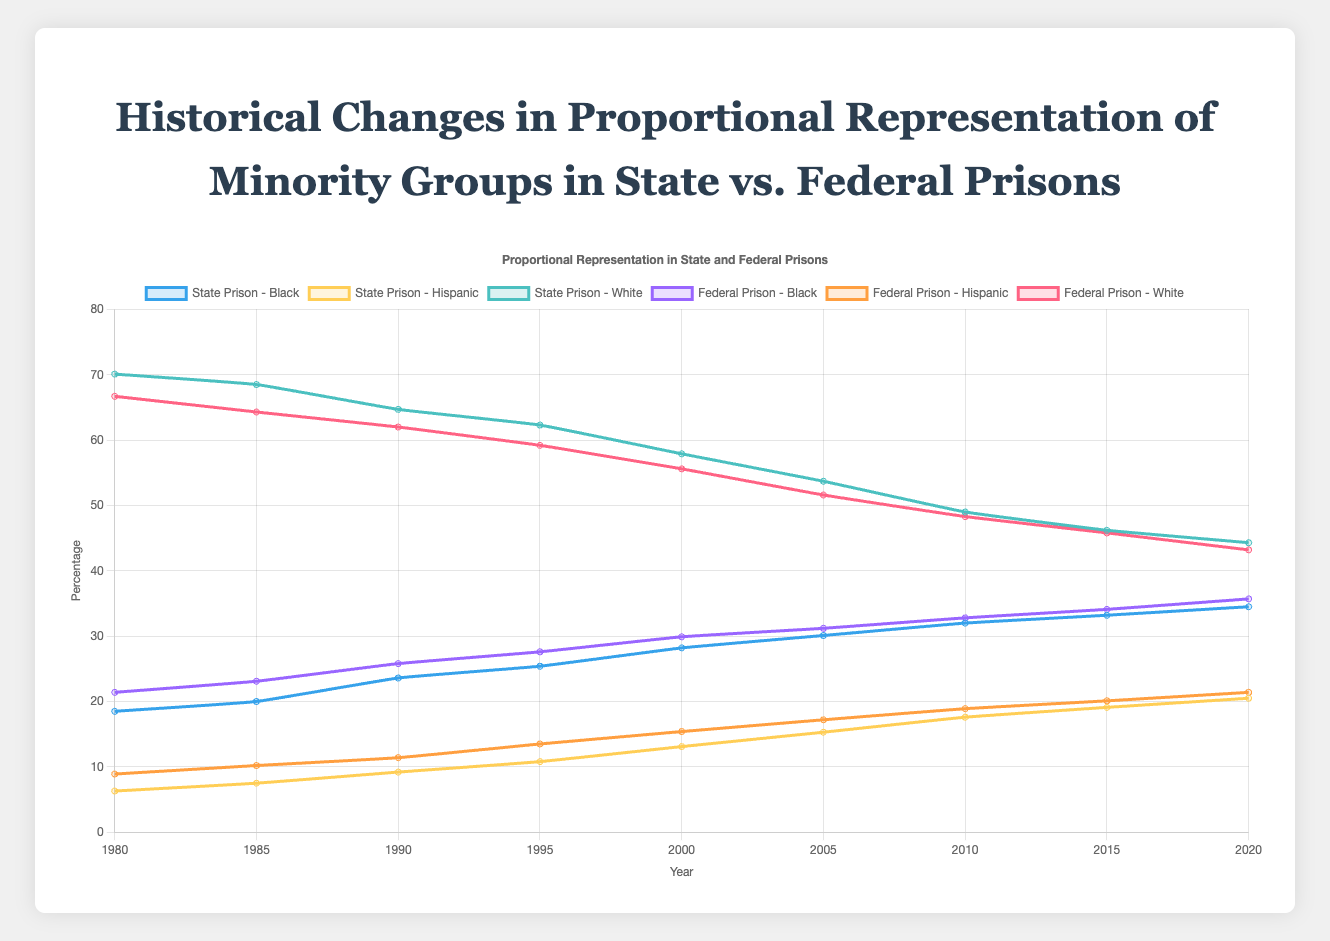What is the trend in the percentage of Black inmates in state prisons from 1980 to 2020? The trend shows a consistent increase in the percentage of Black inmates in state prisons over the years. Starting from 18.5% in 1980, it gradually rises to 34.5% by 2020.
Answer: An increasing trend In 1995, how does the percentage of Hispanic inmates in federal prisons compare to those in state prisons? In 1995, the percentage of Hispanic inmates in federal prisons is 13.5%, while in state prisons it is 10.8%. Comparing the two, the percentage is higher in federal prisons.
Answer: Higher in federal prisons Between 1980 and 2020, which group saw a greater decrease in their representation in state prisons: White or Hispanic inmates? To determine this, we calculate the difference for each group. For White inmates: 70.1% (1980) - 44.3% (2020) = 25.8%. For Hispanic inmates: 20.5% (2020) - 6.3% (1980) = 14.2%. Therefore, White inmates saw a greater decrease.
Answer: White inmates In what year did the percentage of Black inmates in state prisons surpass 30%? By examining the years and the corresponding percentages, we see that in 2005, the percentage of Black inmates in state prisons surpassed 30% for the first time (30.1%).
Answer: 2005 What visual differences can you observe between the trend lines of Hispanic inmates in state and federal prisons? The trend lines for Hispanic inmates in both state and federal prisons show an upward trajectory; however, the line for federal prisons starts higher and remains consistently above the state prison line throughout. Furthermore, both lines are marked in yellow and orange, respectively, with a steady increase over the years.
Answer: Federal lines higher Calculate the average percentage of White inmates in federal prisons over the years. To find the average, sum all the percentages and divide by the number of years: (66.7 + 64.3 + 62 + 59.2 + 55.6 + 51.6 + 48.3 + 45.8 + 43.2) / 9 = 55.2.
Answer: 55.2% In 2010, what is the difference in the percentage of Hispanic inmates between federal and state prisons? The percentage for Hispanic inmates in federal prisons is 18.9%, and in state prisons, it is 17.6%. The difference is 18.9% - 17.6% = 1.3%.
Answer: 1.3% Compare the starting percentage and the ending percentage of Black inmates in federal prisons. How much did it increase by 2020? The starting percentage in 1980 is 21.4%, and the ending percentage in 2020 is 35.7%. The increase is calculated as 35.7% - 21.4% = 14.3%.
Answer: 14.3% What year shows the smallest disparity between the percentage of Black inmates in state and federal prisons? By examining the differences year by year, 1980 shows the smallest disparity with a difference of 21.4% (federal) - 18.5% (state) = 2.9%.
Answer: 1980 Which ethnic group's representation in state prisons shows the most significant consistent increase from 1980 to 2020? The data shows that the representation of Black inmates increases the most consistently from 18.5% in 1980 to 34.5% in 2020.
Answer: Black inmates 